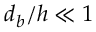Convert formula to latex. <formula><loc_0><loc_0><loc_500><loc_500>d _ { b } / h \ll 1</formula> 